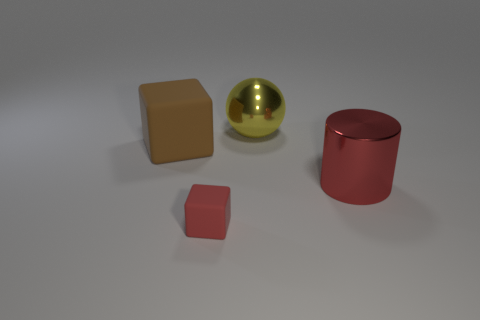Add 2 small red matte blocks. How many objects exist? 6 Subtract all balls. How many objects are left? 3 Add 3 large metal things. How many large metal things are left? 5 Add 1 large red metallic cylinders. How many large red metallic cylinders exist? 2 Subtract 0 purple cylinders. How many objects are left? 4 Subtract all cylinders. Subtract all tiny green balls. How many objects are left? 3 